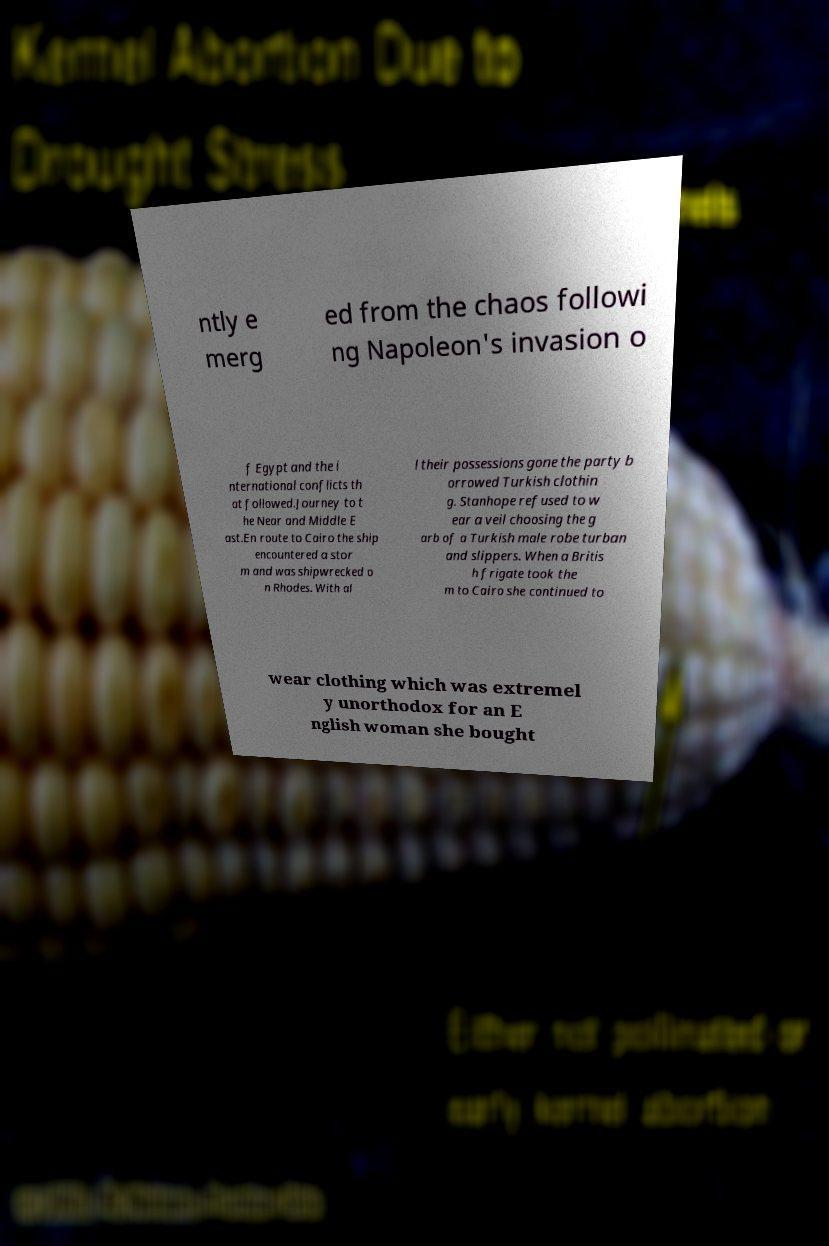Could you assist in decoding the text presented in this image and type it out clearly? ntly e merg ed from the chaos followi ng Napoleon's invasion o f Egypt and the i nternational conflicts th at followed.Journey to t he Near and Middle E ast.En route to Cairo the ship encountered a stor m and was shipwrecked o n Rhodes. With al l their possessions gone the party b orrowed Turkish clothin g. Stanhope refused to w ear a veil choosing the g arb of a Turkish male robe turban and slippers. When a Britis h frigate took the m to Cairo she continued to wear clothing which was extremel y unorthodox for an E nglish woman she bought 